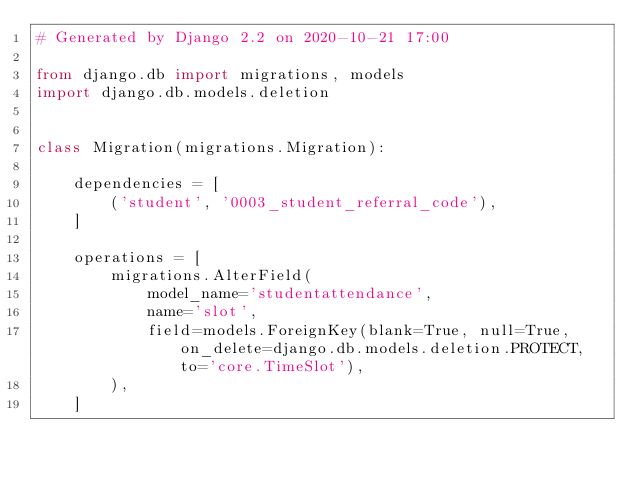Convert code to text. <code><loc_0><loc_0><loc_500><loc_500><_Python_># Generated by Django 2.2 on 2020-10-21 17:00

from django.db import migrations, models
import django.db.models.deletion


class Migration(migrations.Migration):

    dependencies = [
        ('student', '0003_student_referral_code'),
    ]

    operations = [
        migrations.AlterField(
            model_name='studentattendance',
            name='slot',
            field=models.ForeignKey(blank=True, null=True, on_delete=django.db.models.deletion.PROTECT, to='core.TimeSlot'),
        ),
    ]
</code> 